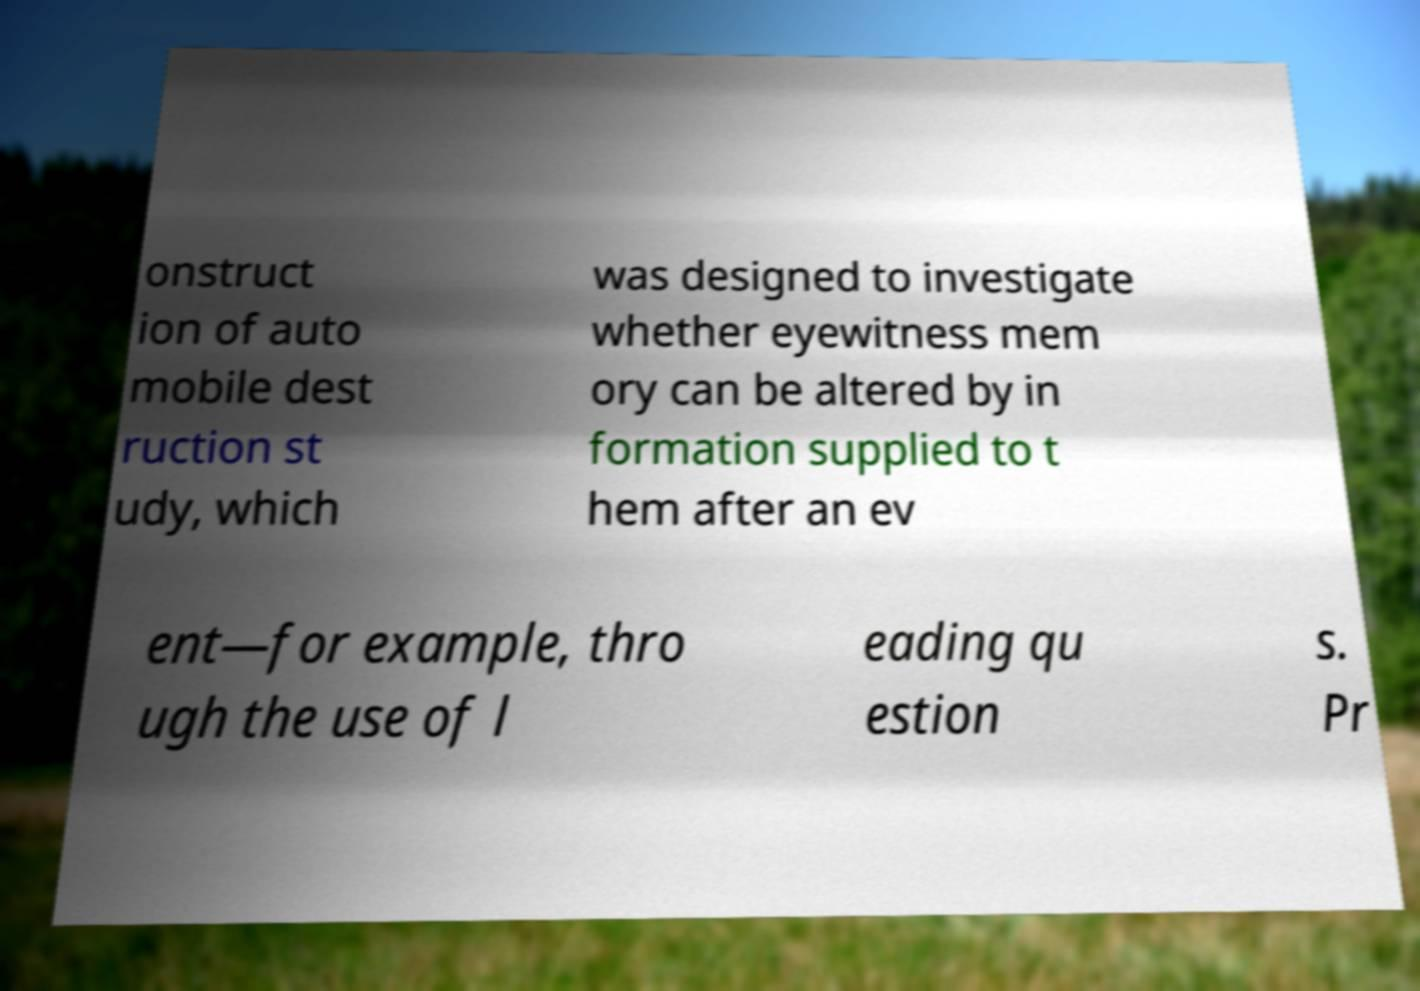Please identify and transcribe the text found in this image. onstruct ion of auto mobile dest ruction st udy, which was designed to investigate whether eyewitness mem ory can be altered by in formation supplied to t hem after an ev ent—for example, thro ugh the use of l eading qu estion s. Pr 